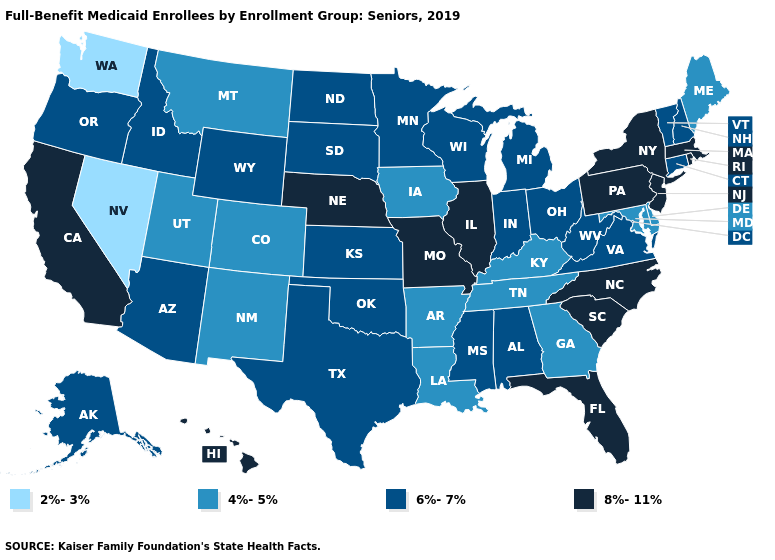Which states have the lowest value in the USA?
Concise answer only. Nevada, Washington. Among the states that border Indiana , does Illinois have the highest value?
Short answer required. Yes. Does the first symbol in the legend represent the smallest category?
Be succinct. Yes. Name the states that have a value in the range 8%-11%?
Be succinct. California, Florida, Hawaii, Illinois, Massachusetts, Missouri, Nebraska, New Jersey, New York, North Carolina, Pennsylvania, Rhode Island, South Carolina. Does Montana have the highest value in the West?
Concise answer only. No. Name the states that have a value in the range 2%-3%?
Keep it brief. Nevada, Washington. Name the states that have a value in the range 8%-11%?
Write a very short answer. California, Florida, Hawaii, Illinois, Massachusetts, Missouri, Nebraska, New Jersey, New York, North Carolina, Pennsylvania, Rhode Island, South Carolina. Which states have the lowest value in the West?
Answer briefly. Nevada, Washington. What is the value of Montana?
Concise answer only. 4%-5%. Among the states that border Wisconsin , does Illinois have the highest value?
Keep it brief. Yes. Name the states that have a value in the range 2%-3%?
Write a very short answer. Nevada, Washington. Name the states that have a value in the range 6%-7%?
Answer briefly. Alabama, Alaska, Arizona, Connecticut, Idaho, Indiana, Kansas, Michigan, Minnesota, Mississippi, New Hampshire, North Dakota, Ohio, Oklahoma, Oregon, South Dakota, Texas, Vermont, Virginia, West Virginia, Wisconsin, Wyoming. Which states hav the highest value in the Northeast?
Be succinct. Massachusetts, New Jersey, New York, Pennsylvania, Rhode Island. Name the states that have a value in the range 4%-5%?
Keep it brief. Arkansas, Colorado, Delaware, Georgia, Iowa, Kentucky, Louisiana, Maine, Maryland, Montana, New Mexico, Tennessee, Utah. 